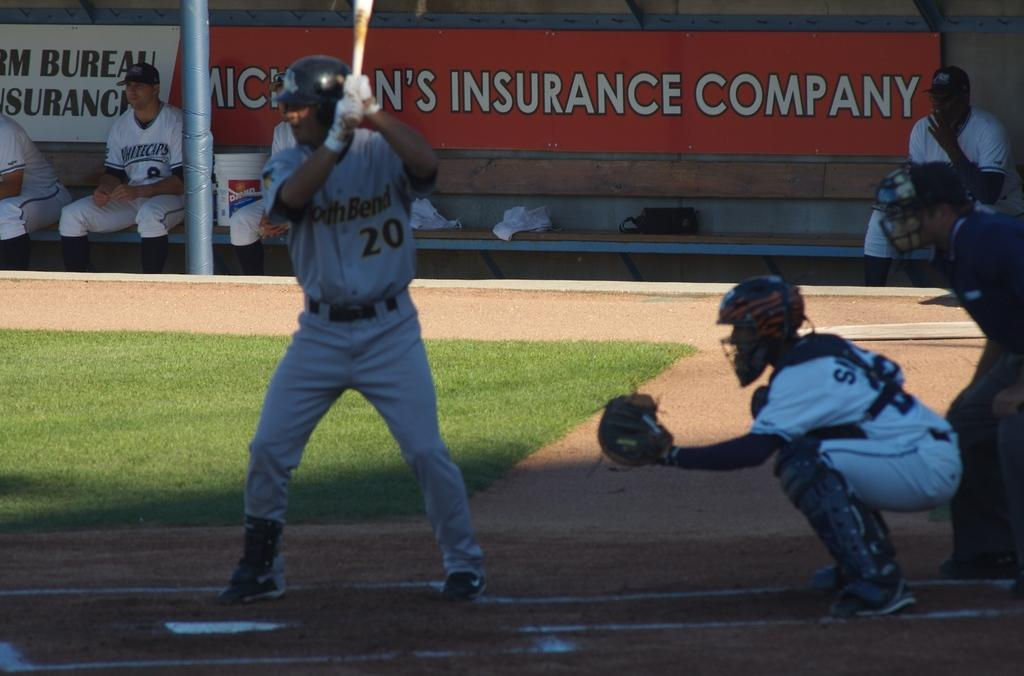<image>
Write a terse but informative summary of the picture. Player number 20 wearing the helmet is up to bat. 